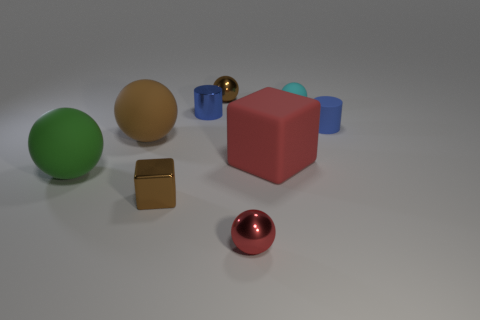What time of day does this scene represent based on the lighting? The lighting in the image is diffused and doesn't give away a strong sense of directionality, which might suggest an indoor setting with artificial lighting rather than any particular time of day. 